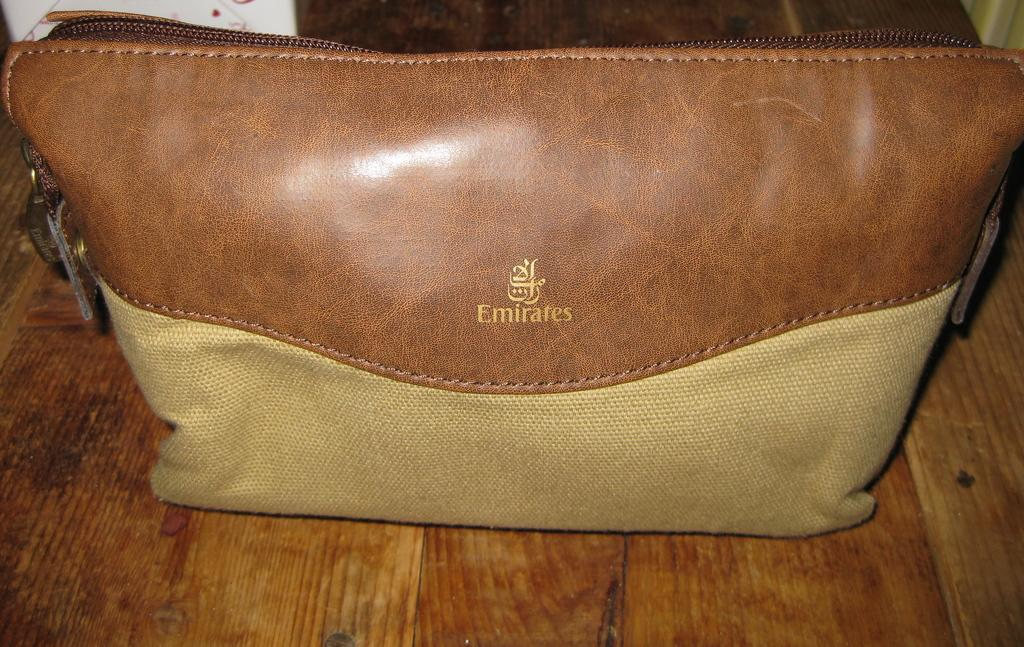What object can be seen in the image? There is a handbag in the image. Where is the handbag located? The handbag is on a table. How does the handbag recess into the table in the image? The handbag does not recess into the table in the image; it is simply placed on top of the table. 